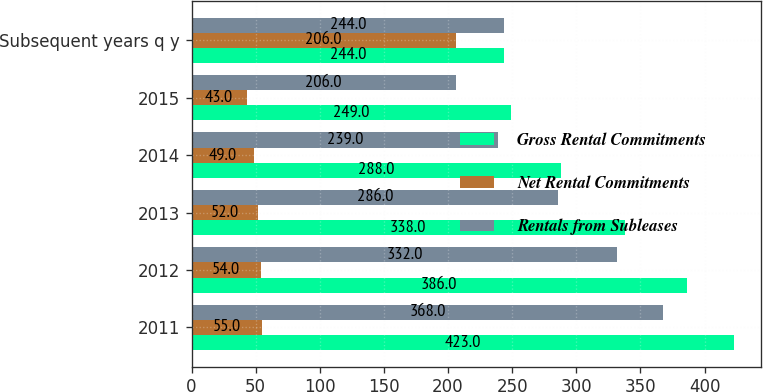Convert chart to OTSL. <chart><loc_0><loc_0><loc_500><loc_500><stacked_bar_chart><ecel><fcel>2011<fcel>2012<fcel>2013<fcel>2014<fcel>2015<fcel>Subsequent years q y<nl><fcel>Gross Rental Commitments<fcel>423<fcel>386<fcel>338<fcel>288<fcel>249<fcel>244<nl><fcel>Net Rental Commitments<fcel>55<fcel>54<fcel>52<fcel>49<fcel>43<fcel>206<nl><fcel>Rentals from Subleases<fcel>368<fcel>332<fcel>286<fcel>239<fcel>206<fcel>244<nl></chart> 